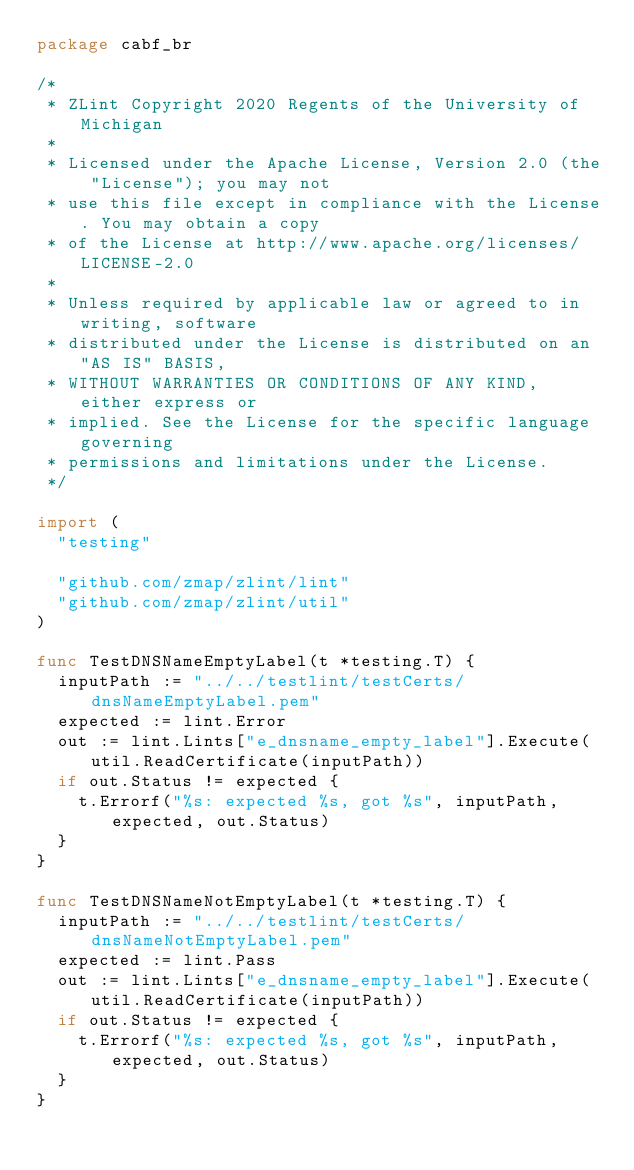<code> <loc_0><loc_0><loc_500><loc_500><_Go_>package cabf_br

/*
 * ZLint Copyright 2020 Regents of the University of Michigan
 *
 * Licensed under the Apache License, Version 2.0 (the "License"); you may not
 * use this file except in compliance with the License. You may obtain a copy
 * of the License at http://www.apache.org/licenses/LICENSE-2.0
 *
 * Unless required by applicable law or agreed to in writing, software
 * distributed under the License is distributed on an "AS IS" BASIS,
 * WITHOUT WARRANTIES OR CONDITIONS OF ANY KIND, either express or
 * implied. See the License for the specific language governing
 * permissions and limitations under the License.
 */

import (
	"testing"

	"github.com/zmap/zlint/lint"
	"github.com/zmap/zlint/util"
)

func TestDNSNameEmptyLabel(t *testing.T) {
	inputPath := "../../testlint/testCerts/dnsNameEmptyLabel.pem"
	expected := lint.Error
	out := lint.Lints["e_dnsname_empty_label"].Execute(util.ReadCertificate(inputPath))
	if out.Status != expected {
		t.Errorf("%s: expected %s, got %s", inputPath, expected, out.Status)
	}
}

func TestDNSNameNotEmptyLabel(t *testing.T) {
	inputPath := "../../testlint/testCerts/dnsNameNotEmptyLabel.pem"
	expected := lint.Pass
	out := lint.Lints["e_dnsname_empty_label"].Execute(util.ReadCertificate(inputPath))
	if out.Status != expected {
		t.Errorf("%s: expected %s, got %s", inputPath, expected, out.Status)
	}
}
</code> 